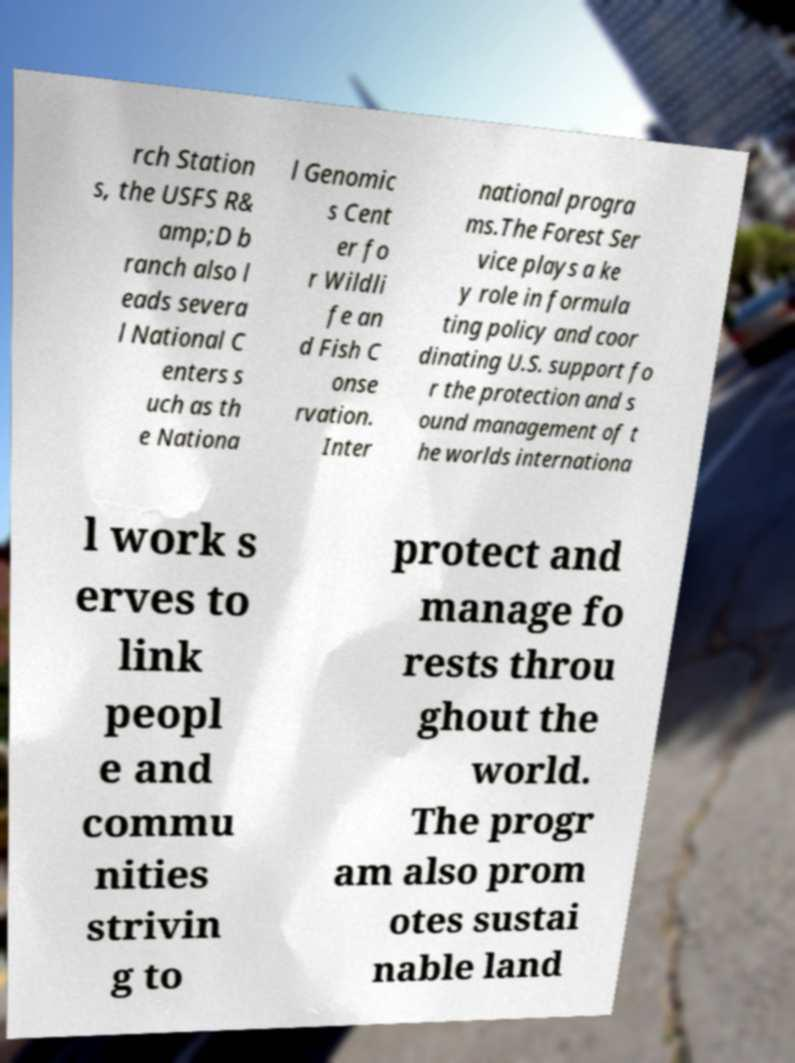Please identify and transcribe the text found in this image. rch Station s, the USFS R& amp;D b ranch also l eads severa l National C enters s uch as th e Nationa l Genomic s Cent er fo r Wildli fe an d Fish C onse rvation. Inter national progra ms.The Forest Ser vice plays a ke y role in formula ting policy and coor dinating U.S. support fo r the protection and s ound management of t he worlds internationa l work s erves to link peopl e and commu nities strivin g to protect and manage fo rests throu ghout the world. The progr am also prom otes sustai nable land 